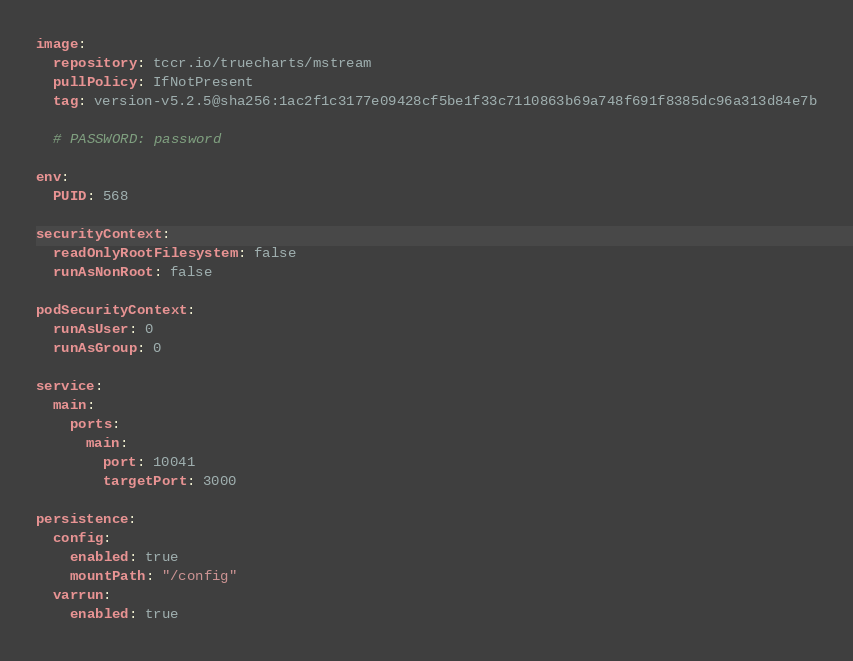<code> <loc_0><loc_0><loc_500><loc_500><_YAML_>image:
  repository: tccr.io/truecharts/mstream
  pullPolicy: IfNotPresent
  tag: version-v5.2.5@sha256:1ac2f1c3177e09428cf5be1f33c7110863b69a748f691f8385dc96a313d84e7b

  # PASSWORD: password

env:
  PUID: 568

securityContext:
  readOnlyRootFilesystem: false
  runAsNonRoot: false

podSecurityContext:
  runAsUser: 0
  runAsGroup: 0

service:
  main:
    ports:
      main:
        port: 10041
        targetPort: 3000

persistence:
  config:
    enabled: true
    mountPath: "/config"
  varrun:
    enabled: true
</code> 